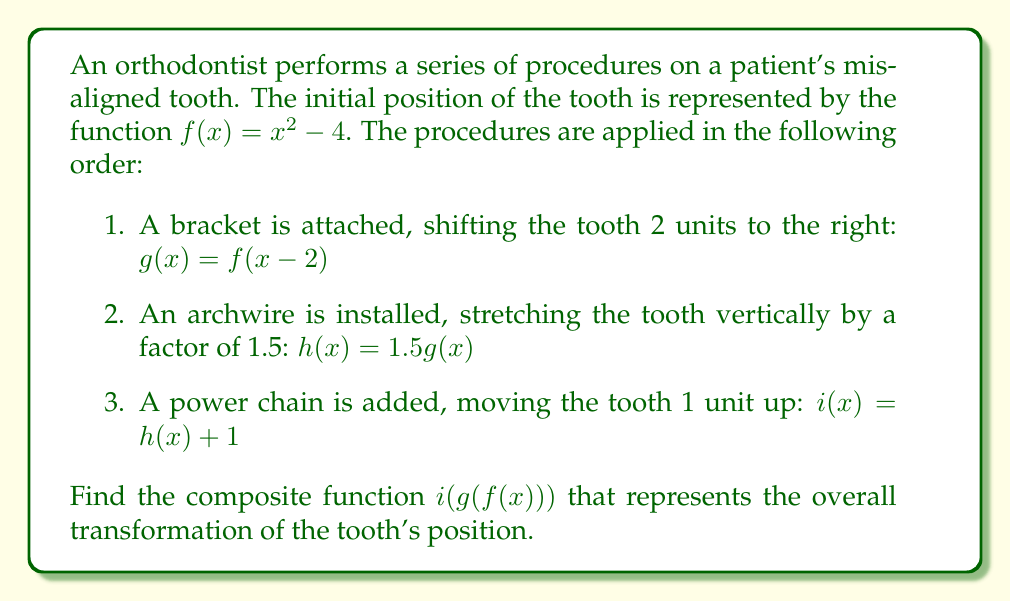Can you answer this question? Let's approach this step-by-step:

1) First, we start with the initial function $f(x) = x^2 - 4$

2) We apply $g(x) = f(x-2)$:
   $g(x) = (x-2)^2 - 4$
   $g(x) = x^2 - 4x + 4 - 4$
   $g(x) = x^2 - 4x$

3) Next, we apply $h(x) = 1.5g(x)$:
   $h(x) = 1.5(x^2 - 4x)$
   $h(x) = 1.5x^2 - 6x$

4) Finally, we apply $i(x) = h(x) + 1$:
   $i(x) = (1.5x^2 - 6x) + 1$
   $i(x) = 1.5x^2 - 6x + 1$

5) Now, to find $i(g(f(x)))$, we need to substitute $f(x)$ into $g(x)$, and then substitute that result into $i(x)$:

   $f(x) = x^2 - 4$
   
   $g(f(x)) = (x^2 - 4)^2 - 4(x^2 - 4)$
   $g(f(x)) = (x^2 - 4)^2 - 4x^2 + 16$
   $g(f(x)) = x^4 - 8x^2 + 16 - 4x^2 + 16$
   $g(f(x)) = x^4 - 12x^2 + 32$

   Now we substitute this into $i(x)$:
   
   $i(g(f(x))) = 1.5(x^4 - 12x^2 + 32) - 6(x^4 - 12x^2 + 32) + 1$
   $i(g(f(x))) = 1.5x^4 - 18x^2 + 48 - 6x^4 + 72x^2 - 192 + 1$
   $i(g(f(x))) = -4.5x^4 + 54x^2 - 143$

Therefore, the composite function representing the overall transformation is $-4.5x^4 + 54x^2 - 143$.
Answer: $-4.5x^4 + 54x^2 - 143$ 